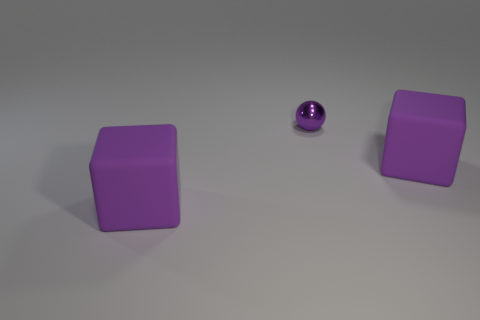Subtract all spheres. How many objects are left? 2 Subtract all blue cylinders. How many gray cubes are left? 0 Subtract all big blocks. Subtract all small balls. How many objects are left? 0 Add 1 small metallic spheres. How many small metallic spheres are left? 2 Add 1 purple objects. How many purple objects exist? 4 Add 2 brown cylinders. How many objects exist? 5 Subtract 0 red balls. How many objects are left? 3 Subtract 1 spheres. How many spheres are left? 0 Subtract all red blocks. Subtract all gray spheres. How many blocks are left? 2 